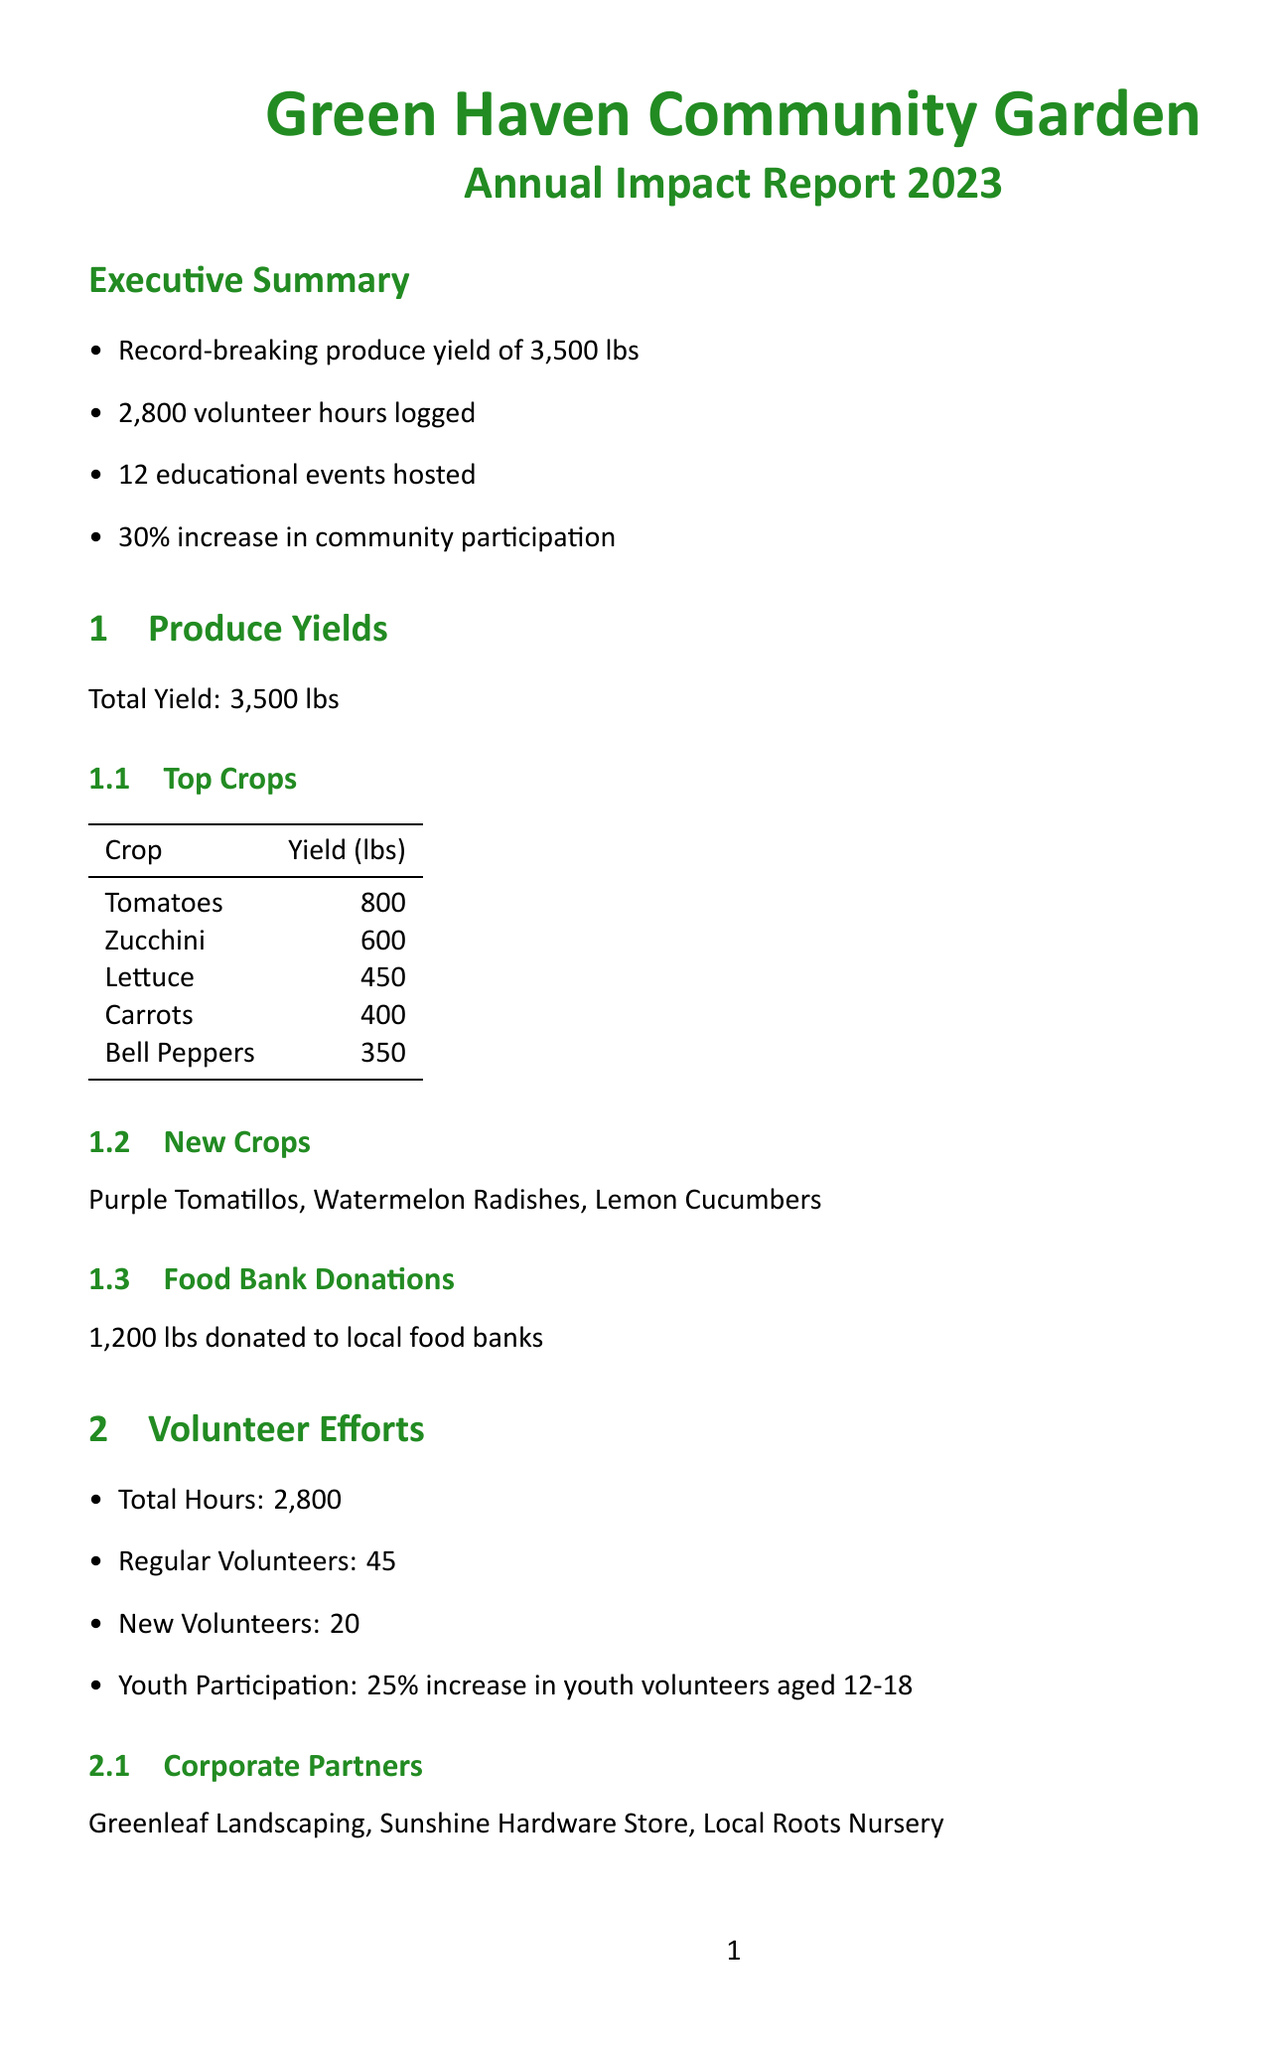What was the total produce yield? The total produce yield is mentioned in the document under produce yields, which states it reached a record-breaking amount.
Answer: 3,500 lbs How many volunteer hours were logged in total? The document specifies the total number of volunteer hours logged in the volunteer efforts section.
Answer: 2,800 What new crops were introduced this year? The section on produce yields lists the new crops that were introduced in the garden this year.
Answer: Purple Tomatillos, Watermelon Radishes, Lemon Cucumbers How many educational events were hosted? The total number of educational events is provided in the educational events section of the report.
Answer: 12 What was the attendance for the Annual Harvest Festival? The attendance figures for community events are listed in the educational events section of the report.
Answer: 250 Which corporate partners were involved? The volunteer efforts section lists the corporate partners that collaborated with the community garden.
Answer: Greenleaf Landscaping, Sunshine Hardware Store, Local Roots Nursery What is one of the future expansion projects? The future plans section outlines potential expansion projects planned for the garden.
Answer: Addition of 10 new raised beds What benefits to the environment are mentioned? The document lists various environmental benefits achieved through the community garden’s efforts.
Answer: Reduction in food miles How has youth participation changed? The report indicates the change in youth participation in volunteer efforts, specifically the age group mentioned.
Answer: 25% increase in youth volunteers aged 12-18 